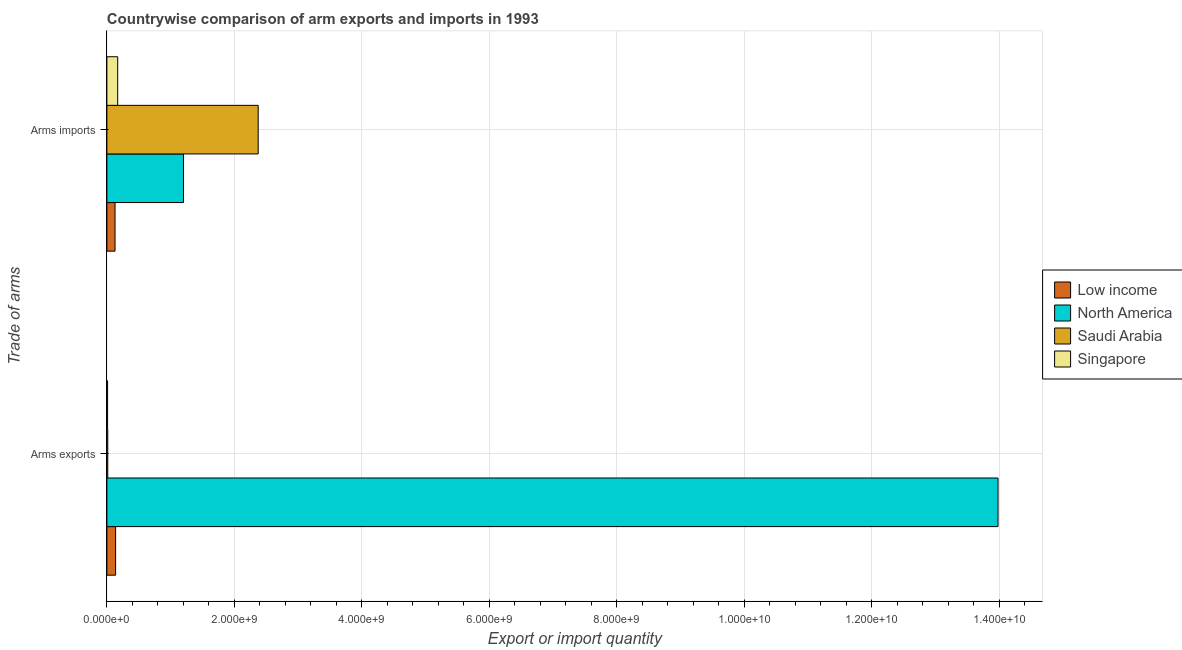How many groups of bars are there?
Your answer should be compact. 2. Are the number of bars per tick equal to the number of legend labels?
Make the answer very short. Yes. Are the number of bars on each tick of the Y-axis equal?
Your response must be concise. Yes. What is the label of the 2nd group of bars from the top?
Offer a terse response. Arms exports. What is the arms imports in North America?
Provide a short and direct response. 1.20e+09. Across all countries, what is the maximum arms imports?
Your answer should be compact. 2.37e+09. Across all countries, what is the minimum arms imports?
Provide a succinct answer. 1.28e+08. What is the total arms exports in the graph?
Keep it short and to the point. 1.41e+1. What is the difference between the arms exports in Low income and that in Singapore?
Provide a succinct answer. 1.26e+08. What is the difference between the arms exports in Low income and the arms imports in North America?
Your response must be concise. -1.06e+09. What is the average arms imports per country?
Offer a terse response. 9.68e+08. What is the difference between the arms imports and arms exports in Low income?
Provide a succinct answer. -9.00e+06. In how many countries, is the arms imports greater than 1200000000 ?
Ensure brevity in your answer.  2. What is the ratio of the arms imports in Low income to that in Singapore?
Make the answer very short. 0.75. Is the arms exports in Singapore less than that in Saudi Arabia?
Your answer should be compact. Yes. In how many countries, is the arms imports greater than the average arms imports taken over all countries?
Your answer should be very brief. 2. What does the 2nd bar from the bottom in Arms exports represents?
Your answer should be very brief. North America. How many bars are there?
Keep it short and to the point. 8. How many countries are there in the graph?
Offer a terse response. 4. What is the difference between two consecutive major ticks on the X-axis?
Keep it short and to the point. 2.00e+09. Are the values on the major ticks of X-axis written in scientific E-notation?
Offer a very short reply. Yes. Does the graph contain grids?
Give a very brief answer. Yes. Where does the legend appear in the graph?
Offer a very short reply. Center right. How many legend labels are there?
Make the answer very short. 4. What is the title of the graph?
Your response must be concise. Countrywise comparison of arm exports and imports in 1993. Does "Congo (Republic)" appear as one of the legend labels in the graph?
Ensure brevity in your answer.  No. What is the label or title of the X-axis?
Your answer should be very brief. Export or import quantity. What is the label or title of the Y-axis?
Give a very brief answer. Trade of arms. What is the Export or import quantity of Low income in Arms exports?
Make the answer very short. 1.37e+08. What is the Export or import quantity of North America in Arms exports?
Offer a very short reply. 1.40e+1. What is the Export or import quantity of Saudi Arabia in Arms exports?
Make the answer very short. 1.40e+07. What is the Export or import quantity in Singapore in Arms exports?
Ensure brevity in your answer.  1.10e+07. What is the Export or import quantity of Low income in Arms imports?
Offer a terse response. 1.28e+08. What is the Export or import quantity in North America in Arms imports?
Provide a succinct answer. 1.20e+09. What is the Export or import quantity of Saudi Arabia in Arms imports?
Provide a succinct answer. 2.37e+09. What is the Export or import quantity in Singapore in Arms imports?
Provide a short and direct response. 1.70e+08. Across all Trade of arms, what is the maximum Export or import quantity in Low income?
Keep it short and to the point. 1.37e+08. Across all Trade of arms, what is the maximum Export or import quantity of North America?
Offer a terse response. 1.40e+1. Across all Trade of arms, what is the maximum Export or import quantity in Saudi Arabia?
Offer a very short reply. 2.37e+09. Across all Trade of arms, what is the maximum Export or import quantity in Singapore?
Keep it short and to the point. 1.70e+08. Across all Trade of arms, what is the minimum Export or import quantity of Low income?
Provide a short and direct response. 1.28e+08. Across all Trade of arms, what is the minimum Export or import quantity of North America?
Your response must be concise. 1.20e+09. Across all Trade of arms, what is the minimum Export or import quantity in Saudi Arabia?
Offer a very short reply. 1.40e+07. Across all Trade of arms, what is the minimum Export or import quantity in Singapore?
Give a very brief answer. 1.10e+07. What is the total Export or import quantity of Low income in the graph?
Offer a very short reply. 2.65e+08. What is the total Export or import quantity in North America in the graph?
Offer a very short reply. 1.52e+1. What is the total Export or import quantity of Saudi Arabia in the graph?
Offer a very short reply. 2.39e+09. What is the total Export or import quantity of Singapore in the graph?
Give a very brief answer. 1.81e+08. What is the difference between the Export or import quantity in Low income in Arms exports and that in Arms imports?
Ensure brevity in your answer.  9.00e+06. What is the difference between the Export or import quantity in North America in Arms exports and that in Arms imports?
Your answer should be very brief. 1.28e+1. What is the difference between the Export or import quantity of Saudi Arabia in Arms exports and that in Arms imports?
Ensure brevity in your answer.  -2.36e+09. What is the difference between the Export or import quantity of Singapore in Arms exports and that in Arms imports?
Your answer should be very brief. -1.59e+08. What is the difference between the Export or import quantity of Low income in Arms exports and the Export or import quantity of North America in Arms imports?
Keep it short and to the point. -1.06e+09. What is the difference between the Export or import quantity of Low income in Arms exports and the Export or import quantity of Saudi Arabia in Arms imports?
Offer a terse response. -2.24e+09. What is the difference between the Export or import quantity in Low income in Arms exports and the Export or import quantity in Singapore in Arms imports?
Your response must be concise. -3.30e+07. What is the difference between the Export or import quantity in North America in Arms exports and the Export or import quantity in Saudi Arabia in Arms imports?
Your answer should be very brief. 1.16e+1. What is the difference between the Export or import quantity of North America in Arms exports and the Export or import quantity of Singapore in Arms imports?
Your answer should be very brief. 1.38e+1. What is the difference between the Export or import quantity in Saudi Arabia in Arms exports and the Export or import quantity in Singapore in Arms imports?
Your answer should be very brief. -1.56e+08. What is the average Export or import quantity of Low income per Trade of arms?
Make the answer very short. 1.32e+08. What is the average Export or import quantity in North America per Trade of arms?
Provide a short and direct response. 7.59e+09. What is the average Export or import quantity in Saudi Arabia per Trade of arms?
Keep it short and to the point. 1.19e+09. What is the average Export or import quantity in Singapore per Trade of arms?
Your answer should be very brief. 9.05e+07. What is the difference between the Export or import quantity in Low income and Export or import quantity in North America in Arms exports?
Provide a succinct answer. -1.38e+1. What is the difference between the Export or import quantity of Low income and Export or import quantity of Saudi Arabia in Arms exports?
Ensure brevity in your answer.  1.23e+08. What is the difference between the Export or import quantity in Low income and Export or import quantity in Singapore in Arms exports?
Your response must be concise. 1.26e+08. What is the difference between the Export or import quantity in North America and Export or import quantity in Saudi Arabia in Arms exports?
Your answer should be very brief. 1.40e+1. What is the difference between the Export or import quantity of North America and Export or import quantity of Singapore in Arms exports?
Keep it short and to the point. 1.40e+1. What is the difference between the Export or import quantity of Saudi Arabia and Export or import quantity of Singapore in Arms exports?
Provide a succinct answer. 3.00e+06. What is the difference between the Export or import quantity in Low income and Export or import quantity in North America in Arms imports?
Your answer should be compact. -1.07e+09. What is the difference between the Export or import quantity of Low income and Export or import quantity of Saudi Arabia in Arms imports?
Make the answer very short. -2.25e+09. What is the difference between the Export or import quantity in Low income and Export or import quantity in Singapore in Arms imports?
Your answer should be very brief. -4.20e+07. What is the difference between the Export or import quantity of North America and Export or import quantity of Saudi Arabia in Arms imports?
Provide a succinct answer. -1.17e+09. What is the difference between the Export or import quantity in North America and Export or import quantity in Singapore in Arms imports?
Give a very brief answer. 1.03e+09. What is the difference between the Export or import quantity of Saudi Arabia and Export or import quantity of Singapore in Arms imports?
Provide a succinct answer. 2.20e+09. What is the ratio of the Export or import quantity of Low income in Arms exports to that in Arms imports?
Your answer should be very brief. 1.07. What is the ratio of the Export or import quantity of North America in Arms exports to that in Arms imports?
Offer a very short reply. 11.63. What is the ratio of the Export or import quantity in Saudi Arabia in Arms exports to that in Arms imports?
Your answer should be compact. 0.01. What is the ratio of the Export or import quantity of Singapore in Arms exports to that in Arms imports?
Your response must be concise. 0.06. What is the difference between the highest and the second highest Export or import quantity of Low income?
Offer a very short reply. 9.00e+06. What is the difference between the highest and the second highest Export or import quantity of North America?
Provide a succinct answer. 1.28e+1. What is the difference between the highest and the second highest Export or import quantity in Saudi Arabia?
Offer a terse response. 2.36e+09. What is the difference between the highest and the second highest Export or import quantity of Singapore?
Ensure brevity in your answer.  1.59e+08. What is the difference between the highest and the lowest Export or import quantity of Low income?
Offer a terse response. 9.00e+06. What is the difference between the highest and the lowest Export or import quantity of North America?
Your answer should be very brief. 1.28e+1. What is the difference between the highest and the lowest Export or import quantity of Saudi Arabia?
Keep it short and to the point. 2.36e+09. What is the difference between the highest and the lowest Export or import quantity of Singapore?
Offer a terse response. 1.59e+08. 